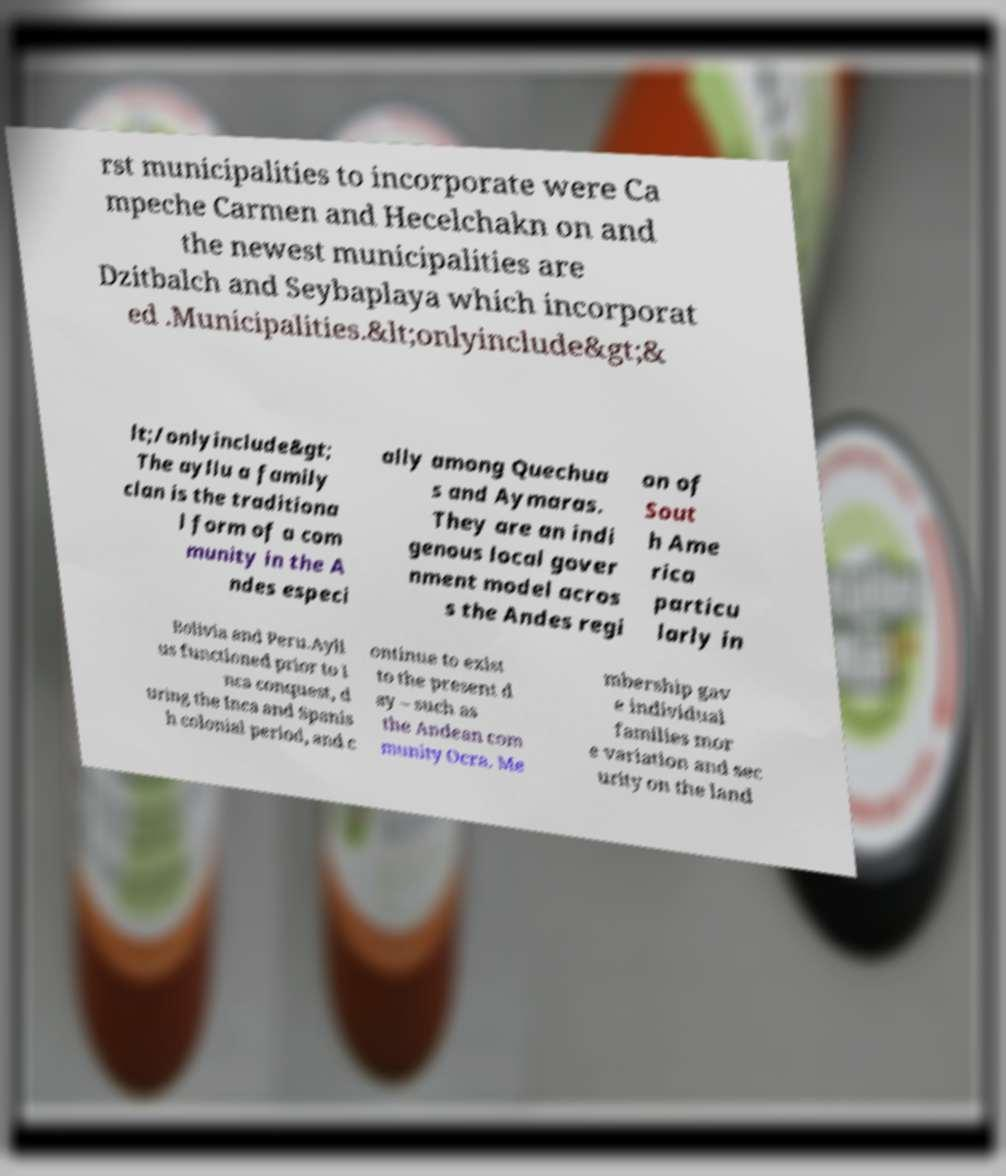For documentation purposes, I need the text within this image transcribed. Could you provide that? rst municipalities to incorporate were Ca mpeche Carmen and Hecelchakn on and the newest municipalities are Dzitbalch and Seybaplaya which incorporat ed .Municipalities.&lt;onlyinclude&gt;& lt;/onlyinclude&gt; The ayllu a family clan is the traditiona l form of a com munity in the A ndes especi ally among Quechua s and Aymaras. They are an indi genous local gover nment model acros s the Andes regi on of Sout h Ame rica particu larly in Bolivia and Peru.Ayll us functioned prior to I nca conquest, d uring the Inca and Spanis h colonial period, and c ontinue to exist to the present d ay – such as the Andean com munity Ocra. Me mbership gav e individual families mor e variation and sec urity on the land 